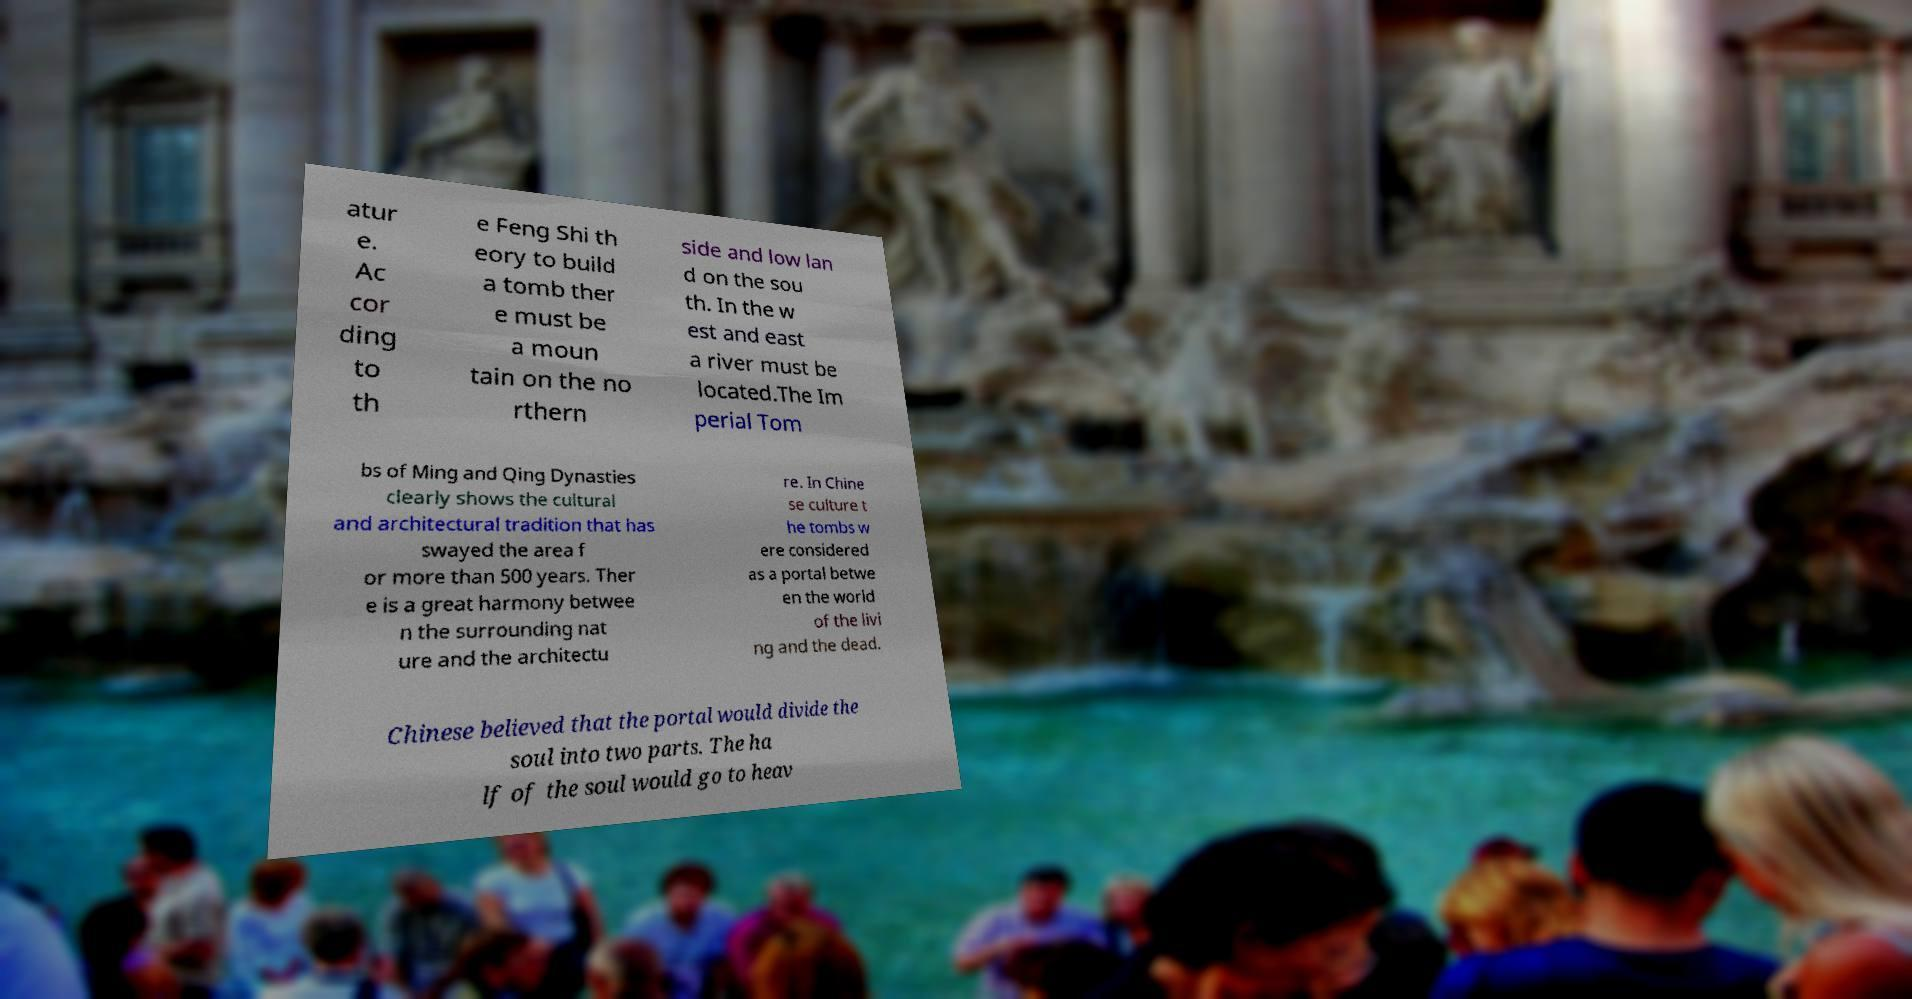Can you read and provide the text displayed in the image?This photo seems to have some interesting text. Can you extract and type it out for me? atur e. Ac cor ding to th e Feng Shi th eory to build a tomb ther e must be a moun tain on the no rthern side and low lan d on the sou th. In the w est and east a river must be located.The Im perial Tom bs of Ming and Qing Dynasties clearly shows the cultural and architectural tradition that has swayed the area f or more than 500 years. Ther e is a great harmony betwee n the surrounding nat ure and the architectu re. In Chine se culture t he tombs w ere considered as a portal betwe en the world of the livi ng and the dead. Chinese believed that the portal would divide the soul into two parts. The ha lf of the soul would go to heav 